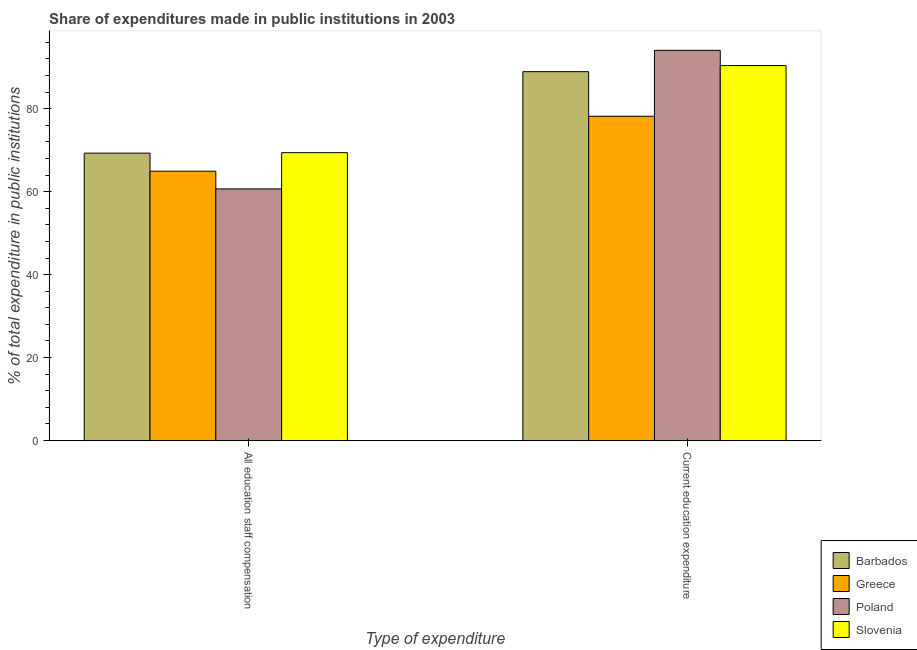How many different coloured bars are there?
Ensure brevity in your answer.  4. How many groups of bars are there?
Make the answer very short. 2. What is the label of the 1st group of bars from the left?
Your answer should be compact. All education staff compensation. What is the expenditure in staff compensation in Slovenia?
Ensure brevity in your answer.  69.39. Across all countries, what is the maximum expenditure in staff compensation?
Keep it short and to the point. 69.39. Across all countries, what is the minimum expenditure in staff compensation?
Offer a terse response. 60.65. In which country was the expenditure in education maximum?
Give a very brief answer. Poland. In which country was the expenditure in staff compensation minimum?
Ensure brevity in your answer.  Poland. What is the total expenditure in staff compensation in the graph?
Offer a terse response. 264.25. What is the difference between the expenditure in staff compensation in Slovenia and that in Greece?
Your answer should be compact. 4.47. What is the difference between the expenditure in staff compensation in Slovenia and the expenditure in education in Barbados?
Offer a very short reply. -19.52. What is the average expenditure in education per country?
Keep it short and to the point. 87.88. What is the difference between the expenditure in education and expenditure in staff compensation in Slovenia?
Give a very brief answer. 20.99. In how many countries, is the expenditure in education greater than 20 %?
Your answer should be very brief. 4. What is the ratio of the expenditure in education in Barbados to that in Slovenia?
Your answer should be compact. 0.98. Is the expenditure in education in Poland less than that in Slovenia?
Keep it short and to the point. No. In how many countries, is the expenditure in education greater than the average expenditure in education taken over all countries?
Keep it short and to the point. 3. What does the 4th bar from the left in All education staff compensation represents?
Offer a very short reply. Slovenia. What does the 3rd bar from the right in All education staff compensation represents?
Your answer should be very brief. Greece. How many bars are there?
Offer a very short reply. 8. Are all the bars in the graph horizontal?
Provide a short and direct response. No. What is the difference between two consecutive major ticks on the Y-axis?
Offer a terse response. 20. How are the legend labels stacked?
Keep it short and to the point. Vertical. What is the title of the graph?
Provide a succinct answer. Share of expenditures made in public institutions in 2003. Does "Kosovo" appear as one of the legend labels in the graph?
Offer a very short reply. No. What is the label or title of the X-axis?
Your answer should be compact. Type of expenditure. What is the label or title of the Y-axis?
Offer a terse response. % of total expenditure in public institutions. What is the % of total expenditure in public institutions of Barbados in All education staff compensation?
Keep it short and to the point. 69.28. What is the % of total expenditure in public institutions in Greece in All education staff compensation?
Ensure brevity in your answer.  64.93. What is the % of total expenditure in public institutions in Poland in All education staff compensation?
Offer a very short reply. 60.65. What is the % of total expenditure in public institutions of Slovenia in All education staff compensation?
Ensure brevity in your answer.  69.39. What is the % of total expenditure in public institutions of Barbados in Current education expenditure?
Make the answer very short. 88.91. What is the % of total expenditure in public institutions in Greece in Current education expenditure?
Give a very brief answer. 78.16. What is the % of total expenditure in public institutions of Poland in Current education expenditure?
Offer a very short reply. 94.05. What is the % of total expenditure in public institutions in Slovenia in Current education expenditure?
Offer a terse response. 90.38. Across all Type of expenditure, what is the maximum % of total expenditure in public institutions in Barbados?
Make the answer very short. 88.91. Across all Type of expenditure, what is the maximum % of total expenditure in public institutions of Greece?
Keep it short and to the point. 78.16. Across all Type of expenditure, what is the maximum % of total expenditure in public institutions of Poland?
Give a very brief answer. 94.05. Across all Type of expenditure, what is the maximum % of total expenditure in public institutions in Slovenia?
Keep it short and to the point. 90.38. Across all Type of expenditure, what is the minimum % of total expenditure in public institutions of Barbados?
Make the answer very short. 69.28. Across all Type of expenditure, what is the minimum % of total expenditure in public institutions of Greece?
Offer a terse response. 64.93. Across all Type of expenditure, what is the minimum % of total expenditure in public institutions of Poland?
Your answer should be compact. 60.65. Across all Type of expenditure, what is the minimum % of total expenditure in public institutions of Slovenia?
Ensure brevity in your answer.  69.39. What is the total % of total expenditure in public institutions of Barbados in the graph?
Provide a short and direct response. 158.19. What is the total % of total expenditure in public institutions of Greece in the graph?
Your response must be concise. 143.09. What is the total % of total expenditure in public institutions in Poland in the graph?
Your answer should be compact. 154.71. What is the total % of total expenditure in public institutions in Slovenia in the graph?
Your answer should be very brief. 159.77. What is the difference between the % of total expenditure in public institutions of Barbados in All education staff compensation and that in Current education expenditure?
Give a very brief answer. -19.64. What is the difference between the % of total expenditure in public institutions in Greece in All education staff compensation and that in Current education expenditure?
Your response must be concise. -13.24. What is the difference between the % of total expenditure in public institutions in Poland in All education staff compensation and that in Current education expenditure?
Provide a short and direct response. -33.4. What is the difference between the % of total expenditure in public institutions in Slovenia in All education staff compensation and that in Current education expenditure?
Offer a terse response. -20.99. What is the difference between the % of total expenditure in public institutions in Barbados in All education staff compensation and the % of total expenditure in public institutions in Greece in Current education expenditure?
Your response must be concise. -8.89. What is the difference between the % of total expenditure in public institutions in Barbados in All education staff compensation and the % of total expenditure in public institutions in Poland in Current education expenditure?
Make the answer very short. -24.78. What is the difference between the % of total expenditure in public institutions of Barbados in All education staff compensation and the % of total expenditure in public institutions of Slovenia in Current education expenditure?
Your answer should be compact. -21.1. What is the difference between the % of total expenditure in public institutions in Greece in All education staff compensation and the % of total expenditure in public institutions in Poland in Current education expenditure?
Provide a succinct answer. -29.13. What is the difference between the % of total expenditure in public institutions of Greece in All education staff compensation and the % of total expenditure in public institutions of Slovenia in Current education expenditure?
Provide a short and direct response. -25.45. What is the difference between the % of total expenditure in public institutions of Poland in All education staff compensation and the % of total expenditure in public institutions of Slovenia in Current education expenditure?
Provide a succinct answer. -29.73. What is the average % of total expenditure in public institutions in Barbados per Type of expenditure?
Keep it short and to the point. 79.1. What is the average % of total expenditure in public institutions of Greece per Type of expenditure?
Ensure brevity in your answer.  71.55. What is the average % of total expenditure in public institutions of Poland per Type of expenditure?
Ensure brevity in your answer.  77.35. What is the average % of total expenditure in public institutions of Slovenia per Type of expenditure?
Keep it short and to the point. 79.88. What is the difference between the % of total expenditure in public institutions in Barbados and % of total expenditure in public institutions in Greece in All education staff compensation?
Offer a very short reply. 4.35. What is the difference between the % of total expenditure in public institutions of Barbados and % of total expenditure in public institutions of Poland in All education staff compensation?
Ensure brevity in your answer.  8.62. What is the difference between the % of total expenditure in public institutions of Barbados and % of total expenditure in public institutions of Slovenia in All education staff compensation?
Offer a very short reply. -0.12. What is the difference between the % of total expenditure in public institutions of Greece and % of total expenditure in public institutions of Poland in All education staff compensation?
Make the answer very short. 4.27. What is the difference between the % of total expenditure in public institutions of Greece and % of total expenditure in public institutions of Slovenia in All education staff compensation?
Your answer should be very brief. -4.47. What is the difference between the % of total expenditure in public institutions of Poland and % of total expenditure in public institutions of Slovenia in All education staff compensation?
Your response must be concise. -8.74. What is the difference between the % of total expenditure in public institutions in Barbados and % of total expenditure in public institutions in Greece in Current education expenditure?
Your answer should be compact. 10.75. What is the difference between the % of total expenditure in public institutions in Barbados and % of total expenditure in public institutions in Poland in Current education expenditure?
Your answer should be very brief. -5.14. What is the difference between the % of total expenditure in public institutions of Barbados and % of total expenditure in public institutions of Slovenia in Current education expenditure?
Offer a very short reply. -1.46. What is the difference between the % of total expenditure in public institutions in Greece and % of total expenditure in public institutions in Poland in Current education expenditure?
Your response must be concise. -15.89. What is the difference between the % of total expenditure in public institutions in Greece and % of total expenditure in public institutions in Slovenia in Current education expenditure?
Give a very brief answer. -12.21. What is the difference between the % of total expenditure in public institutions in Poland and % of total expenditure in public institutions in Slovenia in Current education expenditure?
Your answer should be compact. 3.67. What is the ratio of the % of total expenditure in public institutions in Barbados in All education staff compensation to that in Current education expenditure?
Provide a short and direct response. 0.78. What is the ratio of the % of total expenditure in public institutions of Greece in All education staff compensation to that in Current education expenditure?
Provide a succinct answer. 0.83. What is the ratio of the % of total expenditure in public institutions in Poland in All education staff compensation to that in Current education expenditure?
Your response must be concise. 0.64. What is the ratio of the % of total expenditure in public institutions of Slovenia in All education staff compensation to that in Current education expenditure?
Your answer should be very brief. 0.77. What is the difference between the highest and the second highest % of total expenditure in public institutions in Barbados?
Provide a succinct answer. 19.64. What is the difference between the highest and the second highest % of total expenditure in public institutions in Greece?
Offer a very short reply. 13.24. What is the difference between the highest and the second highest % of total expenditure in public institutions in Poland?
Your answer should be compact. 33.4. What is the difference between the highest and the second highest % of total expenditure in public institutions in Slovenia?
Your answer should be compact. 20.99. What is the difference between the highest and the lowest % of total expenditure in public institutions in Barbados?
Provide a succinct answer. 19.64. What is the difference between the highest and the lowest % of total expenditure in public institutions of Greece?
Ensure brevity in your answer.  13.24. What is the difference between the highest and the lowest % of total expenditure in public institutions of Poland?
Offer a very short reply. 33.4. What is the difference between the highest and the lowest % of total expenditure in public institutions of Slovenia?
Give a very brief answer. 20.99. 